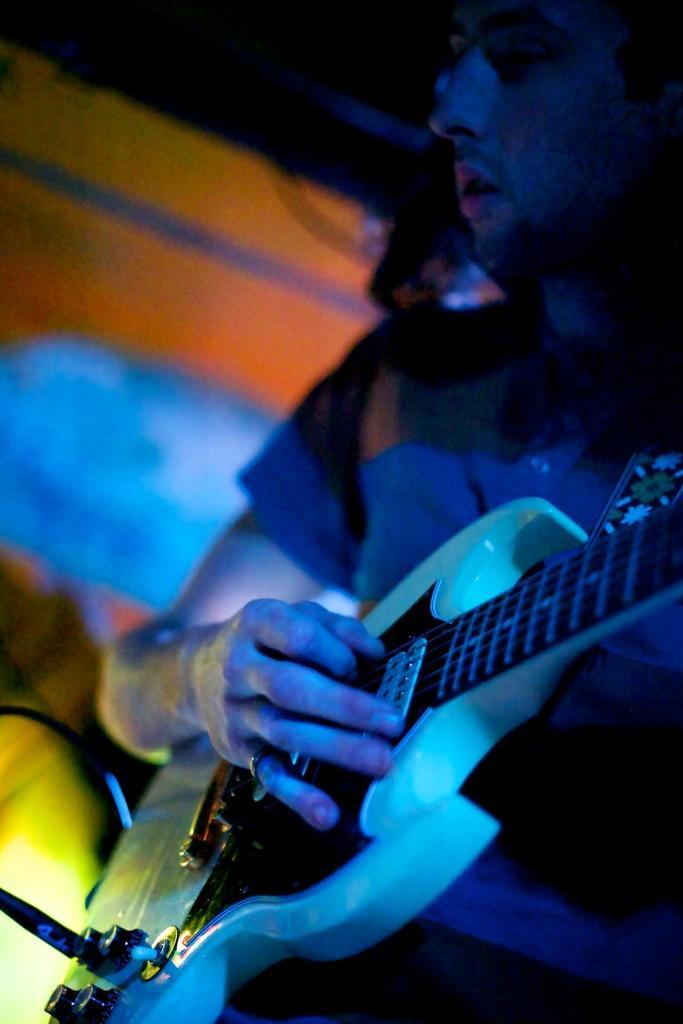Can you describe this image briefly? In this picture we can see a man playing a guitar, there is a blurry background. 